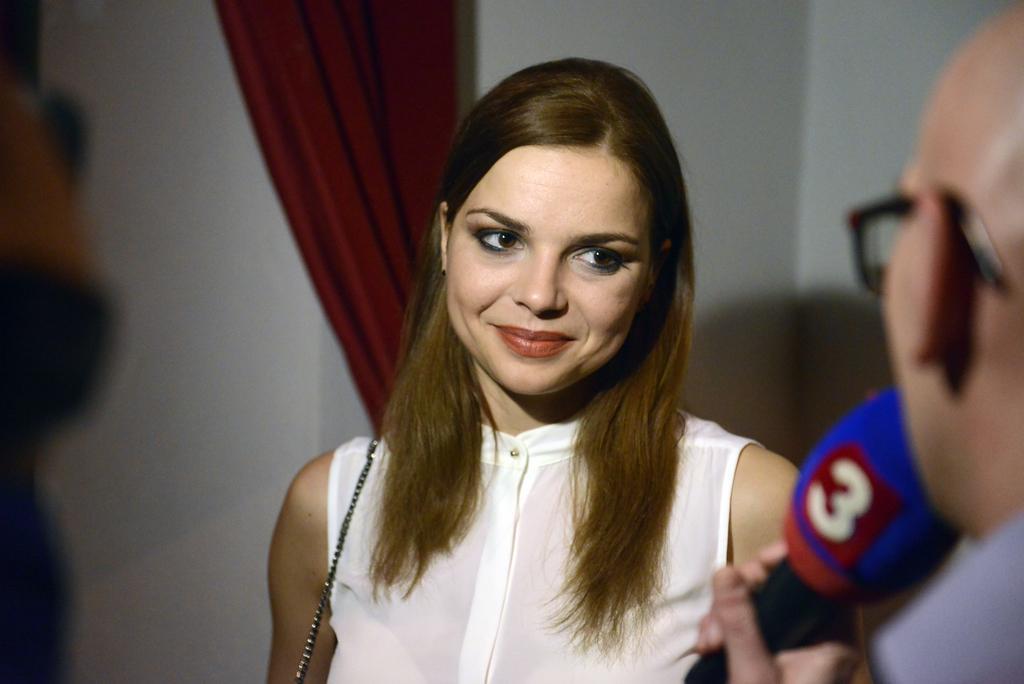Can you describe this image briefly? A woman is standing wearing a white dress. A person is standing holding a microphone. There is a red curtain and white walls. 